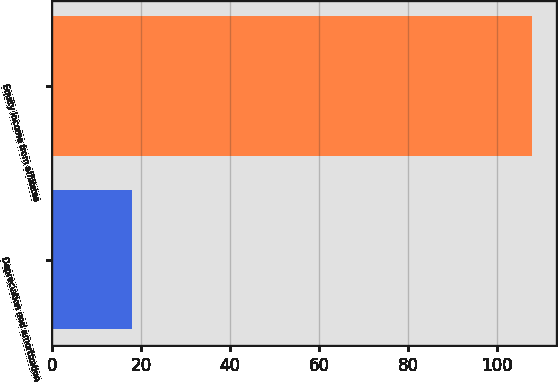Convert chart. <chart><loc_0><loc_0><loc_500><loc_500><bar_chart><fcel>Depreciation and amortization<fcel>Equity income from affiliates<nl><fcel>18<fcel>108<nl></chart> 